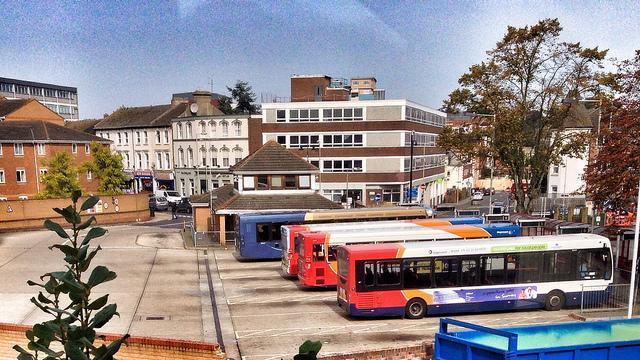How many buses are in the parking lot?
Give a very brief answer. 4. How many buses are visible?
Give a very brief answer. 3. 